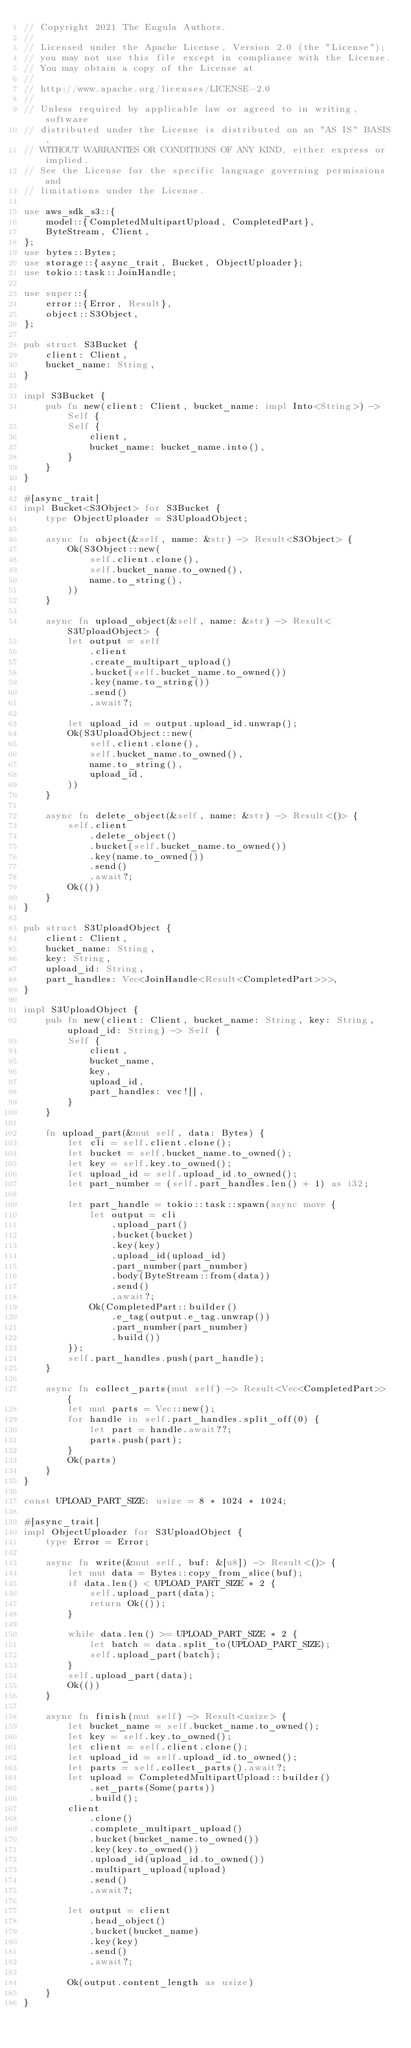<code> <loc_0><loc_0><loc_500><loc_500><_Rust_>// Copyright 2021 The Engula Authors.
//
// Licensed under the Apache License, Version 2.0 (the "License");
// you may not use this file except in compliance with the License.
// You may obtain a copy of the License at
//
// http://www.apache.org/licenses/LICENSE-2.0
//
// Unless required by applicable law or agreed to in writing, software
// distributed under the License is distributed on an "AS IS" BASIS,
// WITHOUT WARRANTIES OR CONDITIONS OF ANY KIND, either express or implied.
// See the License for the specific language governing permissions and
// limitations under the License.

use aws_sdk_s3::{
    model::{CompletedMultipartUpload, CompletedPart},
    ByteStream, Client,
};
use bytes::Bytes;
use storage::{async_trait, Bucket, ObjectUploader};
use tokio::task::JoinHandle;

use super::{
    error::{Error, Result},
    object::S3Object,
};

pub struct S3Bucket {
    client: Client,
    bucket_name: String,
}

impl S3Bucket {
    pub fn new(client: Client, bucket_name: impl Into<String>) -> Self {
        Self {
            client,
            bucket_name: bucket_name.into(),
        }
    }
}

#[async_trait]
impl Bucket<S3Object> for S3Bucket {
    type ObjectUploader = S3UploadObject;

    async fn object(&self, name: &str) -> Result<S3Object> {
        Ok(S3Object::new(
            self.client.clone(),
            self.bucket_name.to_owned(),
            name.to_string(),
        ))
    }

    async fn upload_object(&self, name: &str) -> Result<S3UploadObject> {
        let output = self
            .client
            .create_multipart_upload()
            .bucket(self.bucket_name.to_owned())
            .key(name.to_string())
            .send()
            .await?;

        let upload_id = output.upload_id.unwrap();
        Ok(S3UploadObject::new(
            self.client.clone(),
            self.bucket_name.to_owned(),
            name.to_string(),
            upload_id,
        ))
    }

    async fn delete_object(&self, name: &str) -> Result<()> {
        self.client
            .delete_object()
            .bucket(self.bucket_name.to_owned())
            .key(name.to_owned())
            .send()
            .await?;
        Ok(())
    }
}

pub struct S3UploadObject {
    client: Client,
    bucket_name: String,
    key: String,
    upload_id: String,
    part_handles: Vec<JoinHandle<Result<CompletedPart>>>,
}

impl S3UploadObject {
    pub fn new(client: Client, bucket_name: String, key: String, upload_id: String) -> Self {
        Self {
            client,
            bucket_name,
            key,
            upload_id,
            part_handles: vec![],
        }
    }

    fn upload_part(&mut self, data: Bytes) {
        let cli = self.client.clone();
        let bucket = self.bucket_name.to_owned();
        let key = self.key.to_owned();
        let upload_id = self.upload_id.to_owned();
        let part_number = (self.part_handles.len() + 1) as i32;

        let part_handle = tokio::task::spawn(async move {
            let output = cli
                .upload_part()
                .bucket(bucket)
                .key(key)
                .upload_id(upload_id)
                .part_number(part_number)
                .body(ByteStream::from(data))
                .send()
                .await?;
            Ok(CompletedPart::builder()
                .e_tag(output.e_tag.unwrap())
                .part_number(part_number)
                .build())
        });
        self.part_handles.push(part_handle);
    }

    async fn collect_parts(mut self) -> Result<Vec<CompletedPart>> {
        let mut parts = Vec::new();
        for handle in self.part_handles.split_off(0) {
            let part = handle.await??;
            parts.push(part);
        }
        Ok(parts)
    }
}

const UPLOAD_PART_SIZE: usize = 8 * 1024 * 1024;

#[async_trait]
impl ObjectUploader for S3UploadObject {
    type Error = Error;

    async fn write(&mut self, buf: &[u8]) -> Result<()> {
        let mut data = Bytes::copy_from_slice(buf);
        if data.len() < UPLOAD_PART_SIZE * 2 {
            self.upload_part(data);
            return Ok(());
        }

        while data.len() >= UPLOAD_PART_SIZE * 2 {
            let batch = data.split_to(UPLOAD_PART_SIZE);
            self.upload_part(batch);
        }
        self.upload_part(data);
        Ok(())
    }

    async fn finish(mut self) -> Result<usize> {
        let bucket_name = self.bucket_name.to_owned();
        let key = self.key.to_owned();
        let client = self.client.clone();
        let upload_id = self.upload_id.to_owned();
        let parts = self.collect_parts().await?;
        let upload = CompletedMultipartUpload::builder()
            .set_parts(Some(parts))
            .build();
        client
            .clone()
            .complete_multipart_upload()
            .bucket(bucket_name.to_owned())
            .key(key.to_owned())
            .upload_id(upload_id.to_owned())
            .multipart_upload(upload)
            .send()
            .await?;

        let output = client
            .head_object()
            .bucket(bucket_name)
            .key(key)
            .send()
            .await?;

        Ok(output.content_length as usize)
    }
}
</code> 